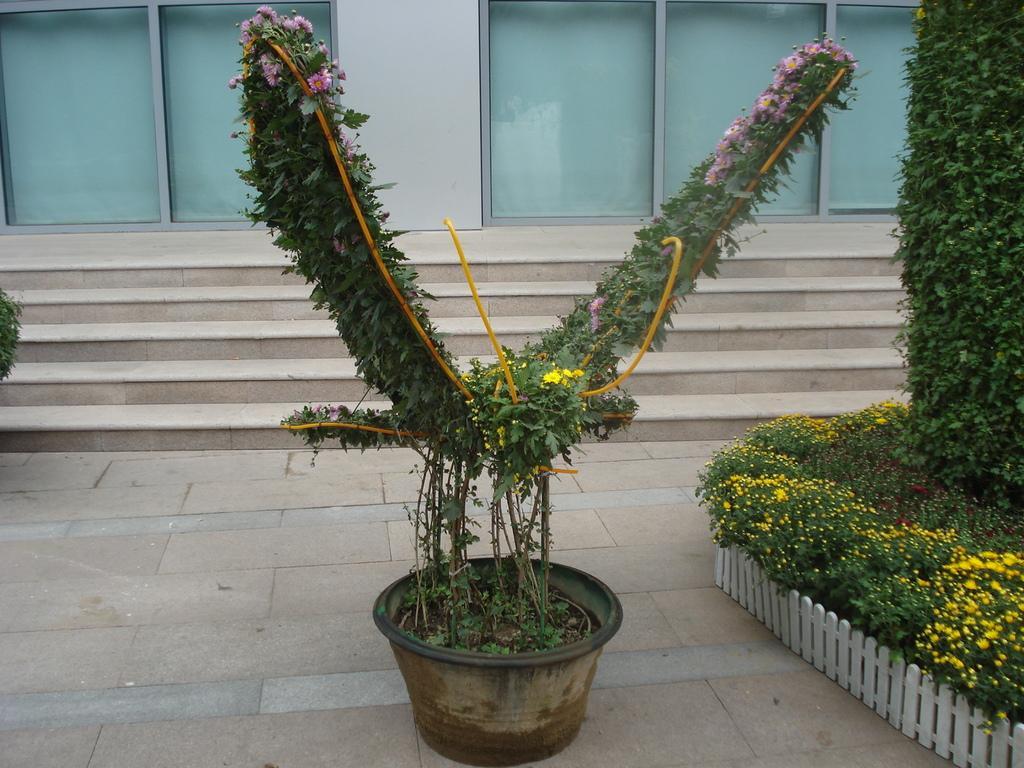Could you give a brief overview of what you see in this image? This picture is clicked outside. In the center there is a pot containing a plant. On the right we can see the plants and a white color fence. In the background we can see the wall of a building and the stairs and also the windows. 